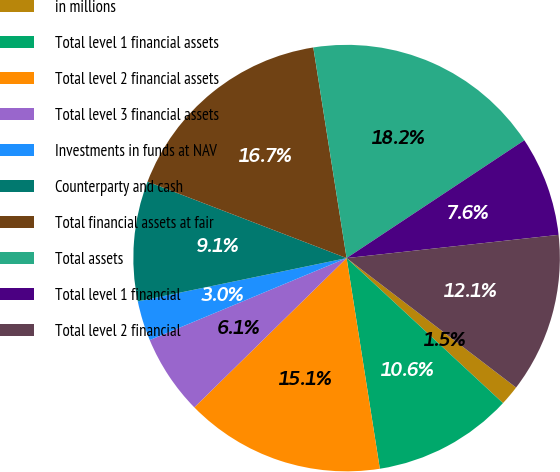Convert chart to OTSL. <chart><loc_0><loc_0><loc_500><loc_500><pie_chart><fcel>in millions<fcel>Total level 1 financial assets<fcel>Total level 2 financial assets<fcel>Total level 3 financial assets<fcel>Investments in funds at NAV<fcel>Counterparty and cash<fcel>Total financial assets at fair<fcel>Total assets<fcel>Total level 1 financial<fcel>Total level 2 financial<nl><fcel>1.52%<fcel>10.61%<fcel>15.15%<fcel>6.06%<fcel>3.03%<fcel>9.09%<fcel>16.67%<fcel>18.18%<fcel>7.58%<fcel>12.12%<nl></chart> 